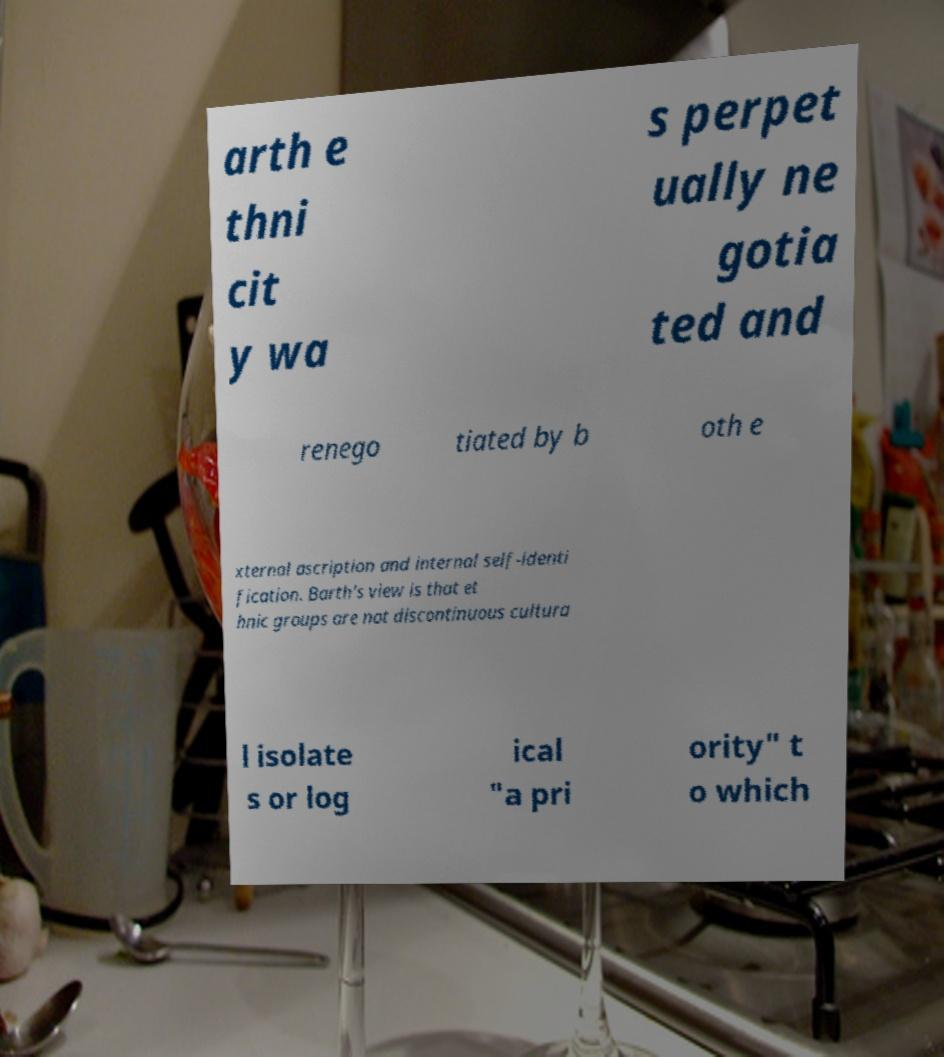Please identify and transcribe the text found in this image. arth e thni cit y wa s perpet ually ne gotia ted and renego tiated by b oth e xternal ascription and internal self-identi fication. Barth's view is that et hnic groups are not discontinuous cultura l isolate s or log ical "a pri ority" t o which 